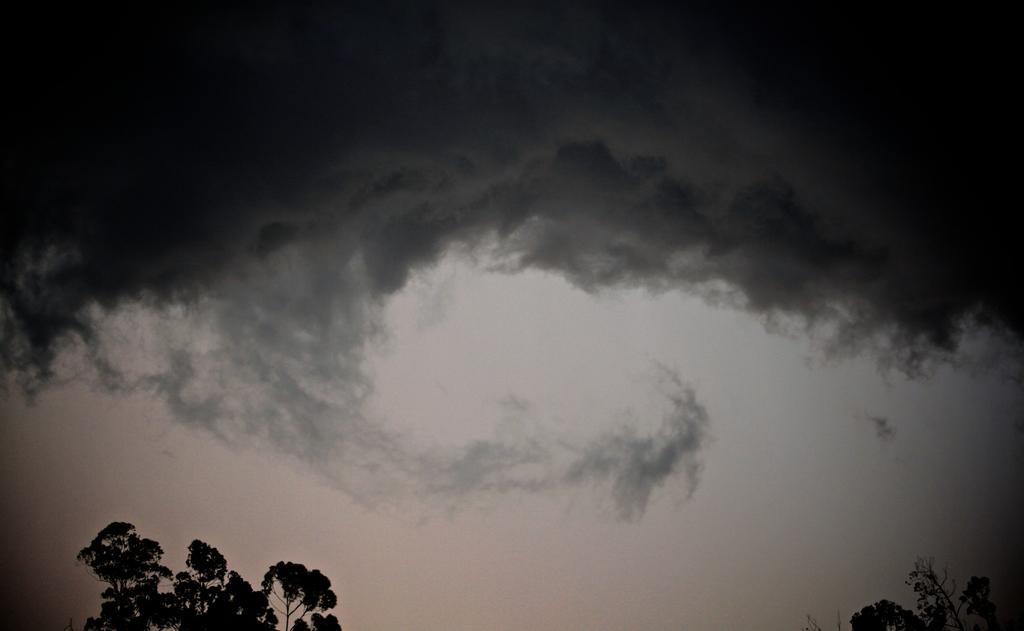How would you summarize this image in a sentence or two? In this picture we can see trees and in the background we can see the sky with clouds. 